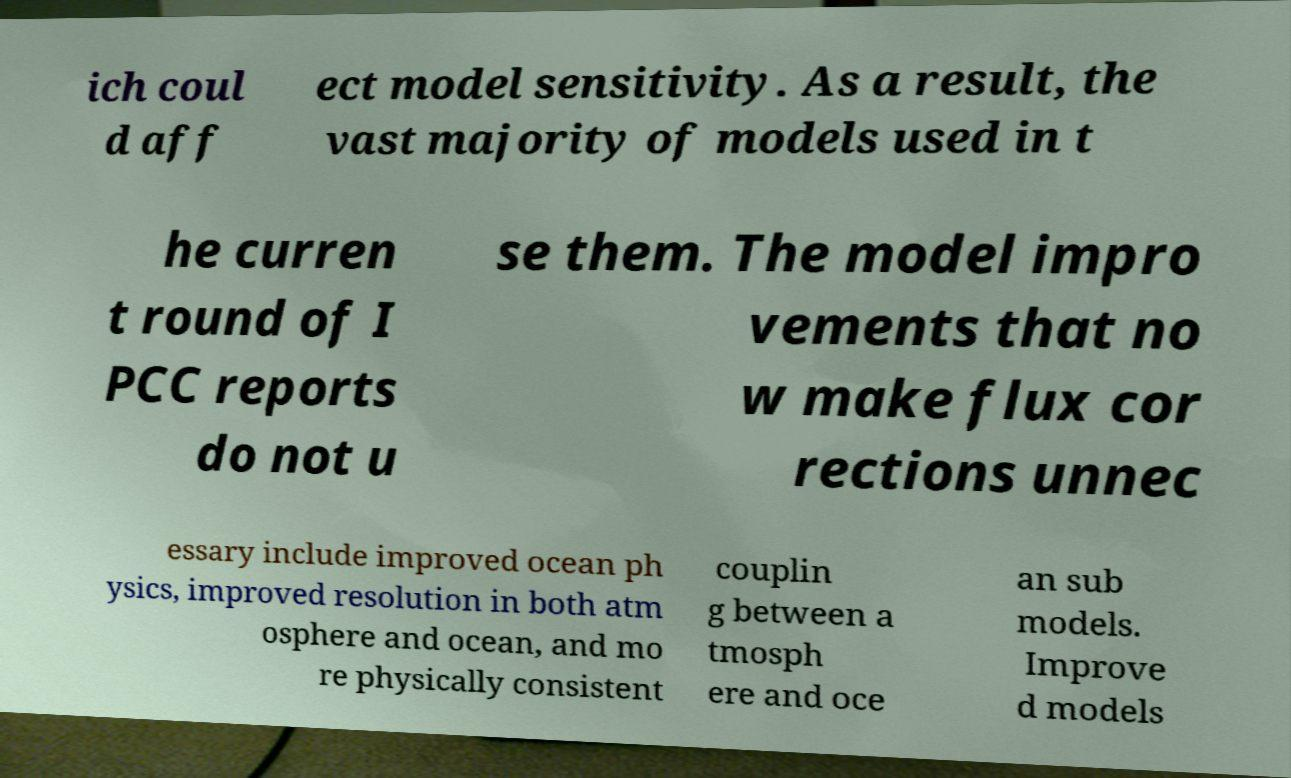I need the written content from this picture converted into text. Can you do that? ich coul d aff ect model sensitivity. As a result, the vast majority of models used in t he curren t round of I PCC reports do not u se them. The model impro vements that no w make flux cor rections unnec essary include improved ocean ph ysics, improved resolution in both atm osphere and ocean, and mo re physically consistent couplin g between a tmosph ere and oce an sub models. Improve d models 